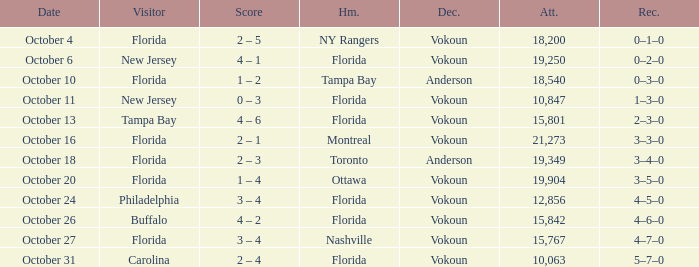Which team won when the visitor was Carolina? Vokoun. 